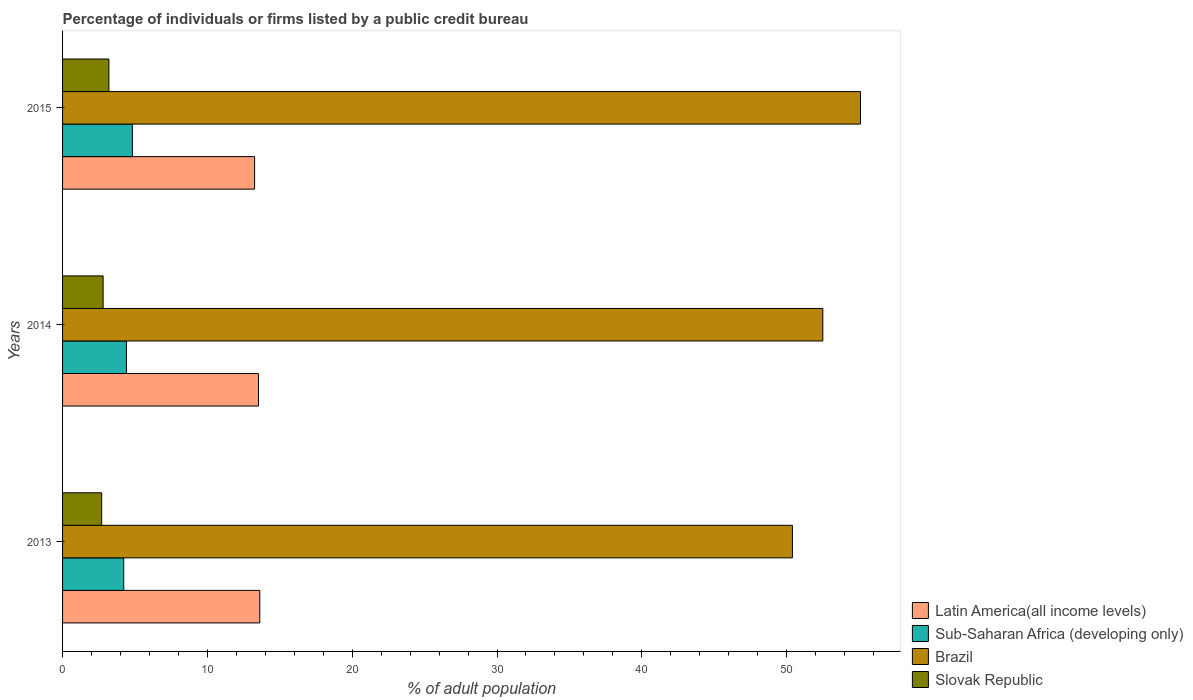How many different coloured bars are there?
Provide a short and direct response. 4. How many groups of bars are there?
Your response must be concise. 3. Are the number of bars per tick equal to the number of legend labels?
Keep it short and to the point. Yes. What is the label of the 2nd group of bars from the top?
Your answer should be very brief. 2014. In how many cases, is the number of bars for a given year not equal to the number of legend labels?
Offer a terse response. 0. What is the percentage of population listed by a public credit bureau in Latin America(all income levels) in 2015?
Ensure brevity in your answer.  13.26. Across all years, what is the maximum percentage of population listed by a public credit bureau in Brazil?
Provide a succinct answer. 55.1. Across all years, what is the minimum percentage of population listed by a public credit bureau in Latin America(all income levels)?
Your answer should be very brief. 13.26. In which year was the percentage of population listed by a public credit bureau in Sub-Saharan Africa (developing only) maximum?
Your response must be concise. 2015. In which year was the percentage of population listed by a public credit bureau in Latin America(all income levels) minimum?
Your response must be concise. 2015. What is the total percentage of population listed by a public credit bureau in Brazil in the graph?
Keep it short and to the point. 158. What is the difference between the percentage of population listed by a public credit bureau in Sub-Saharan Africa (developing only) in 2013 and that in 2015?
Give a very brief answer. -0.6. What is the difference between the percentage of population listed by a public credit bureau in Sub-Saharan Africa (developing only) in 2014 and the percentage of population listed by a public credit bureau in Slovak Republic in 2013?
Your answer should be very brief. 1.71. What is the average percentage of population listed by a public credit bureau in Brazil per year?
Give a very brief answer. 52.67. In the year 2015, what is the difference between the percentage of population listed by a public credit bureau in Sub-Saharan Africa (developing only) and percentage of population listed by a public credit bureau in Latin America(all income levels)?
Offer a very short reply. -8.44. In how many years, is the percentage of population listed by a public credit bureau in Slovak Republic greater than 40 %?
Offer a terse response. 0. What is the ratio of the percentage of population listed by a public credit bureau in Latin America(all income levels) in 2013 to that in 2015?
Your answer should be compact. 1.03. Is the percentage of population listed by a public credit bureau in Brazil in 2013 less than that in 2014?
Your response must be concise. Yes. Is the difference between the percentage of population listed by a public credit bureau in Sub-Saharan Africa (developing only) in 2013 and 2015 greater than the difference between the percentage of population listed by a public credit bureau in Latin America(all income levels) in 2013 and 2015?
Offer a very short reply. No. What is the difference between the highest and the second highest percentage of population listed by a public credit bureau in Slovak Republic?
Give a very brief answer. 0.4. What is the difference between the highest and the lowest percentage of population listed by a public credit bureau in Latin America(all income levels)?
Your answer should be very brief. 0.36. Is the sum of the percentage of population listed by a public credit bureau in Sub-Saharan Africa (developing only) in 2013 and 2015 greater than the maximum percentage of population listed by a public credit bureau in Latin America(all income levels) across all years?
Give a very brief answer. No. Is it the case that in every year, the sum of the percentage of population listed by a public credit bureau in Latin America(all income levels) and percentage of population listed by a public credit bureau in Brazil is greater than the sum of percentage of population listed by a public credit bureau in Sub-Saharan Africa (developing only) and percentage of population listed by a public credit bureau in Slovak Republic?
Keep it short and to the point. Yes. What does the 1st bar from the top in 2014 represents?
Make the answer very short. Slovak Republic. What does the 4th bar from the bottom in 2015 represents?
Your answer should be very brief. Slovak Republic. Is it the case that in every year, the sum of the percentage of population listed by a public credit bureau in Slovak Republic and percentage of population listed by a public credit bureau in Brazil is greater than the percentage of population listed by a public credit bureau in Latin America(all income levels)?
Make the answer very short. Yes. How many bars are there?
Your response must be concise. 12. How many years are there in the graph?
Keep it short and to the point. 3. Are the values on the major ticks of X-axis written in scientific E-notation?
Ensure brevity in your answer.  No. Does the graph contain any zero values?
Provide a short and direct response. No. How are the legend labels stacked?
Give a very brief answer. Vertical. What is the title of the graph?
Provide a succinct answer. Percentage of individuals or firms listed by a public credit bureau. What is the label or title of the X-axis?
Your answer should be very brief. % of adult population. What is the % of adult population of Latin America(all income levels) in 2013?
Offer a terse response. 13.62. What is the % of adult population in Sub-Saharan Africa (developing only) in 2013?
Provide a succinct answer. 4.22. What is the % of adult population of Brazil in 2013?
Your response must be concise. 50.4. What is the % of adult population in Latin America(all income levels) in 2014?
Your answer should be compact. 13.53. What is the % of adult population in Sub-Saharan Africa (developing only) in 2014?
Offer a very short reply. 4.41. What is the % of adult population of Brazil in 2014?
Offer a very short reply. 52.5. What is the % of adult population of Latin America(all income levels) in 2015?
Ensure brevity in your answer.  13.26. What is the % of adult population of Sub-Saharan Africa (developing only) in 2015?
Offer a very short reply. 4.82. What is the % of adult population in Brazil in 2015?
Offer a very short reply. 55.1. Across all years, what is the maximum % of adult population of Latin America(all income levels)?
Offer a very short reply. 13.62. Across all years, what is the maximum % of adult population of Sub-Saharan Africa (developing only)?
Ensure brevity in your answer.  4.82. Across all years, what is the maximum % of adult population in Brazil?
Your response must be concise. 55.1. Across all years, what is the minimum % of adult population of Latin America(all income levels)?
Offer a very short reply. 13.26. Across all years, what is the minimum % of adult population of Sub-Saharan Africa (developing only)?
Your answer should be compact. 4.22. Across all years, what is the minimum % of adult population of Brazil?
Your response must be concise. 50.4. Across all years, what is the minimum % of adult population of Slovak Republic?
Provide a succinct answer. 2.7. What is the total % of adult population of Latin America(all income levels) in the graph?
Keep it short and to the point. 40.41. What is the total % of adult population of Sub-Saharan Africa (developing only) in the graph?
Ensure brevity in your answer.  13.46. What is the total % of adult population in Brazil in the graph?
Your answer should be compact. 158. What is the total % of adult population of Slovak Republic in the graph?
Give a very brief answer. 8.7. What is the difference between the % of adult population of Latin America(all income levels) in 2013 and that in 2014?
Your response must be concise. 0.09. What is the difference between the % of adult population of Sub-Saharan Africa (developing only) in 2013 and that in 2014?
Provide a succinct answer. -0.19. What is the difference between the % of adult population in Slovak Republic in 2013 and that in 2014?
Offer a terse response. -0.1. What is the difference between the % of adult population in Latin America(all income levels) in 2013 and that in 2015?
Your answer should be compact. 0.36. What is the difference between the % of adult population in Sub-Saharan Africa (developing only) in 2013 and that in 2015?
Your answer should be very brief. -0.6. What is the difference between the % of adult population in Brazil in 2013 and that in 2015?
Ensure brevity in your answer.  -4.7. What is the difference between the % of adult population of Latin America(all income levels) in 2014 and that in 2015?
Your answer should be very brief. 0.27. What is the difference between the % of adult population in Sub-Saharan Africa (developing only) in 2014 and that in 2015?
Offer a very short reply. -0.41. What is the difference between the % of adult population in Latin America(all income levels) in 2013 and the % of adult population in Sub-Saharan Africa (developing only) in 2014?
Make the answer very short. 9.21. What is the difference between the % of adult population in Latin America(all income levels) in 2013 and the % of adult population in Brazil in 2014?
Provide a succinct answer. -38.88. What is the difference between the % of adult population of Latin America(all income levels) in 2013 and the % of adult population of Slovak Republic in 2014?
Your response must be concise. 10.82. What is the difference between the % of adult population in Sub-Saharan Africa (developing only) in 2013 and the % of adult population in Brazil in 2014?
Provide a succinct answer. -48.28. What is the difference between the % of adult population of Sub-Saharan Africa (developing only) in 2013 and the % of adult population of Slovak Republic in 2014?
Your response must be concise. 1.42. What is the difference between the % of adult population of Brazil in 2013 and the % of adult population of Slovak Republic in 2014?
Provide a succinct answer. 47.6. What is the difference between the % of adult population of Latin America(all income levels) in 2013 and the % of adult population of Sub-Saharan Africa (developing only) in 2015?
Provide a short and direct response. 8.8. What is the difference between the % of adult population in Latin America(all income levels) in 2013 and the % of adult population in Brazil in 2015?
Your response must be concise. -41.48. What is the difference between the % of adult population of Latin America(all income levels) in 2013 and the % of adult population of Slovak Republic in 2015?
Offer a very short reply. 10.42. What is the difference between the % of adult population of Sub-Saharan Africa (developing only) in 2013 and the % of adult population of Brazil in 2015?
Give a very brief answer. -50.88. What is the difference between the % of adult population in Sub-Saharan Africa (developing only) in 2013 and the % of adult population in Slovak Republic in 2015?
Keep it short and to the point. 1.02. What is the difference between the % of adult population in Brazil in 2013 and the % of adult population in Slovak Republic in 2015?
Make the answer very short. 47.2. What is the difference between the % of adult population of Latin America(all income levels) in 2014 and the % of adult population of Sub-Saharan Africa (developing only) in 2015?
Your response must be concise. 8.71. What is the difference between the % of adult population in Latin America(all income levels) in 2014 and the % of adult population in Brazil in 2015?
Provide a succinct answer. -41.57. What is the difference between the % of adult population in Latin America(all income levels) in 2014 and the % of adult population in Slovak Republic in 2015?
Your answer should be very brief. 10.33. What is the difference between the % of adult population in Sub-Saharan Africa (developing only) in 2014 and the % of adult population in Brazil in 2015?
Keep it short and to the point. -50.69. What is the difference between the % of adult population in Sub-Saharan Africa (developing only) in 2014 and the % of adult population in Slovak Republic in 2015?
Your answer should be compact. 1.21. What is the difference between the % of adult population in Brazil in 2014 and the % of adult population in Slovak Republic in 2015?
Your answer should be very brief. 49.3. What is the average % of adult population in Latin America(all income levels) per year?
Keep it short and to the point. 13.47. What is the average % of adult population in Sub-Saharan Africa (developing only) per year?
Your answer should be very brief. 4.49. What is the average % of adult population in Brazil per year?
Ensure brevity in your answer.  52.67. In the year 2013, what is the difference between the % of adult population in Latin America(all income levels) and % of adult population in Sub-Saharan Africa (developing only)?
Your answer should be very brief. 9.39. In the year 2013, what is the difference between the % of adult population of Latin America(all income levels) and % of adult population of Brazil?
Offer a very short reply. -36.78. In the year 2013, what is the difference between the % of adult population of Latin America(all income levels) and % of adult population of Slovak Republic?
Provide a short and direct response. 10.92. In the year 2013, what is the difference between the % of adult population in Sub-Saharan Africa (developing only) and % of adult population in Brazil?
Your answer should be compact. -46.18. In the year 2013, what is the difference between the % of adult population in Sub-Saharan Africa (developing only) and % of adult population in Slovak Republic?
Offer a terse response. 1.52. In the year 2013, what is the difference between the % of adult population in Brazil and % of adult population in Slovak Republic?
Your answer should be compact. 47.7. In the year 2014, what is the difference between the % of adult population in Latin America(all income levels) and % of adult population in Sub-Saharan Africa (developing only)?
Make the answer very short. 9.12. In the year 2014, what is the difference between the % of adult population in Latin America(all income levels) and % of adult population in Brazil?
Provide a succinct answer. -38.97. In the year 2014, what is the difference between the % of adult population in Latin America(all income levels) and % of adult population in Slovak Republic?
Provide a succinct answer. 10.73. In the year 2014, what is the difference between the % of adult population of Sub-Saharan Africa (developing only) and % of adult population of Brazil?
Ensure brevity in your answer.  -48.09. In the year 2014, what is the difference between the % of adult population in Sub-Saharan Africa (developing only) and % of adult population in Slovak Republic?
Make the answer very short. 1.61. In the year 2014, what is the difference between the % of adult population of Brazil and % of adult population of Slovak Republic?
Provide a short and direct response. 49.7. In the year 2015, what is the difference between the % of adult population in Latin America(all income levels) and % of adult population in Sub-Saharan Africa (developing only)?
Your answer should be compact. 8.44. In the year 2015, what is the difference between the % of adult population in Latin America(all income levels) and % of adult population in Brazil?
Your answer should be very brief. -41.84. In the year 2015, what is the difference between the % of adult population in Latin America(all income levels) and % of adult population in Slovak Republic?
Provide a succinct answer. 10.06. In the year 2015, what is the difference between the % of adult population of Sub-Saharan Africa (developing only) and % of adult population of Brazil?
Your answer should be very brief. -50.28. In the year 2015, what is the difference between the % of adult population of Sub-Saharan Africa (developing only) and % of adult population of Slovak Republic?
Offer a very short reply. 1.62. In the year 2015, what is the difference between the % of adult population of Brazil and % of adult population of Slovak Republic?
Provide a succinct answer. 51.9. What is the ratio of the % of adult population of Latin America(all income levels) in 2013 to that in 2014?
Give a very brief answer. 1.01. What is the ratio of the % of adult population in Sub-Saharan Africa (developing only) in 2013 to that in 2014?
Keep it short and to the point. 0.96. What is the ratio of the % of adult population of Brazil in 2013 to that in 2014?
Make the answer very short. 0.96. What is the ratio of the % of adult population of Sub-Saharan Africa (developing only) in 2013 to that in 2015?
Offer a terse response. 0.88. What is the ratio of the % of adult population in Brazil in 2013 to that in 2015?
Keep it short and to the point. 0.91. What is the ratio of the % of adult population in Slovak Republic in 2013 to that in 2015?
Your answer should be very brief. 0.84. What is the ratio of the % of adult population of Latin America(all income levels) in 2014 to that in 2015?
Ensure brevity in your answer.  1.02. What is the ratio of the % of adult population in Sub-Saharan Africa (developing only) in 2014 to that in 2015?
Offer a very short reply. 0.91. What is the ratio of the % of adult population of Brazil in 2014 to that in 2015?
Keep it short and to the point. 0.95. What is the ratio of the % of adult population in Slovak Republic in 2014 to that in 2015?
Provide a succinct answer. 0.88. What is the difference between the highest and the second highest % of adult population of Latin America(all income levels)?
Your response must be concise. 0.09. What is the difference between the highest and the second highest % of adult population in Sub-Saharan Africa (developing only)?
Your response must be concise. 0.41. What is the difference between the highest and the second highest % of adult population of Slovak Republic?
Your answer should be compact. 0.4. What is the difference between the highest and the lowest % of adult population of Latin America(all income levels)?
Provide a succinct answer. 0.36. What is the difference between the highest and the lowest % of adult population of Sub-Saharan Africa (developing only)?
Make the answer very short. 0.6. What is the difference between the highest and the lowest % of adult population of Slovak Republic?
Offer a terse response. 0.5. 